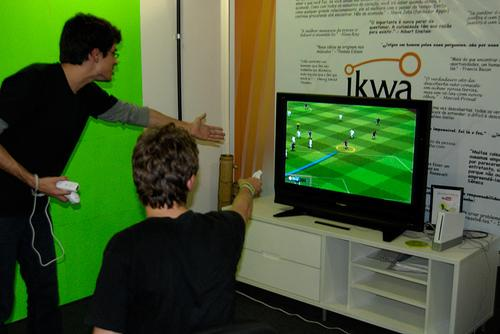What do these young people pretend to do?

Choices:
A) strum guitar
B) play soccer
C) play tennis
D) bike play soccer 